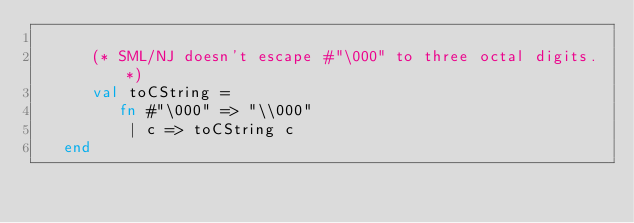<code> <loc_0><loc_0><loc_500><loc_500><_SML_>
      (* SML/NJ doesn't escape #"\000" to three octal digits. *)
      val toCString =
         fn #"\000" => "\\000"
          | c => toCString c
   end
</code> 